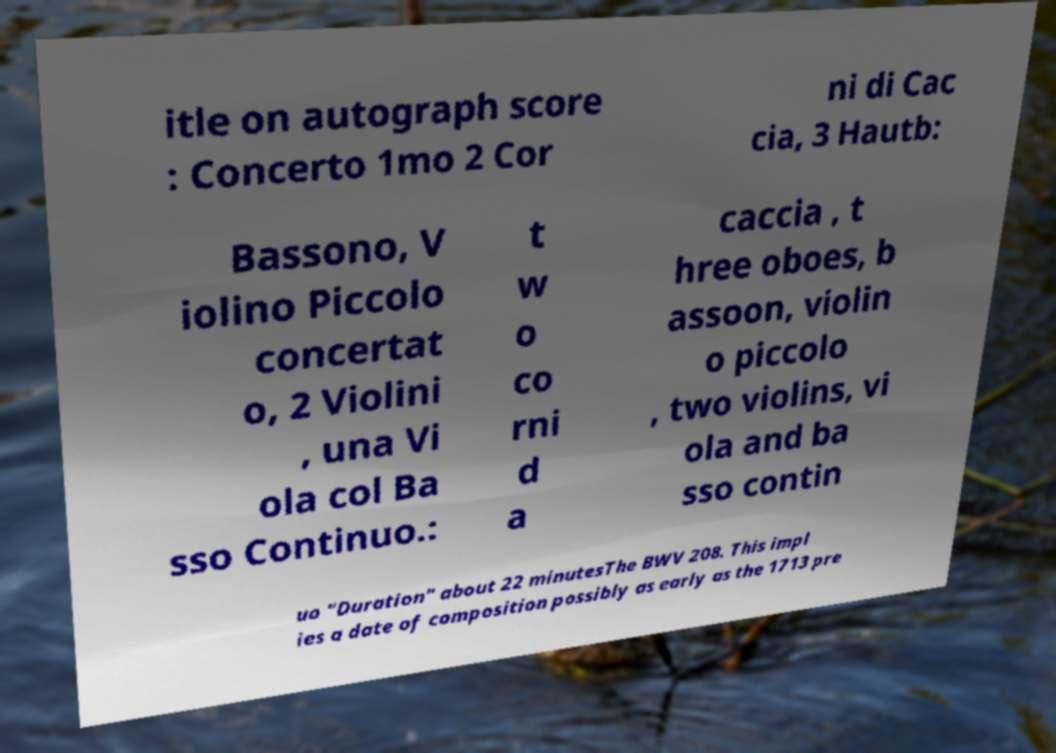Can you read and provide the text displayed in the image?This photo seems to have some interesting text. Can you extract and type it out for me? itle on autograph score : Concerto 1mo 2 Cor ni di Cac cia, 3 Hautb: Bassono, V iolino Piccolo concertat o, 2 Violini , una Vi ola col Ba sso Continuo.: t w o co rni d a caccia , t hree oboes, b assoon, violin o piccolo , two violins, vi ola and ba sso contin uo "Duration" about 22 minutesThe BWV 208. This impl ies a date of composition possibly as early as the 1713 pre 